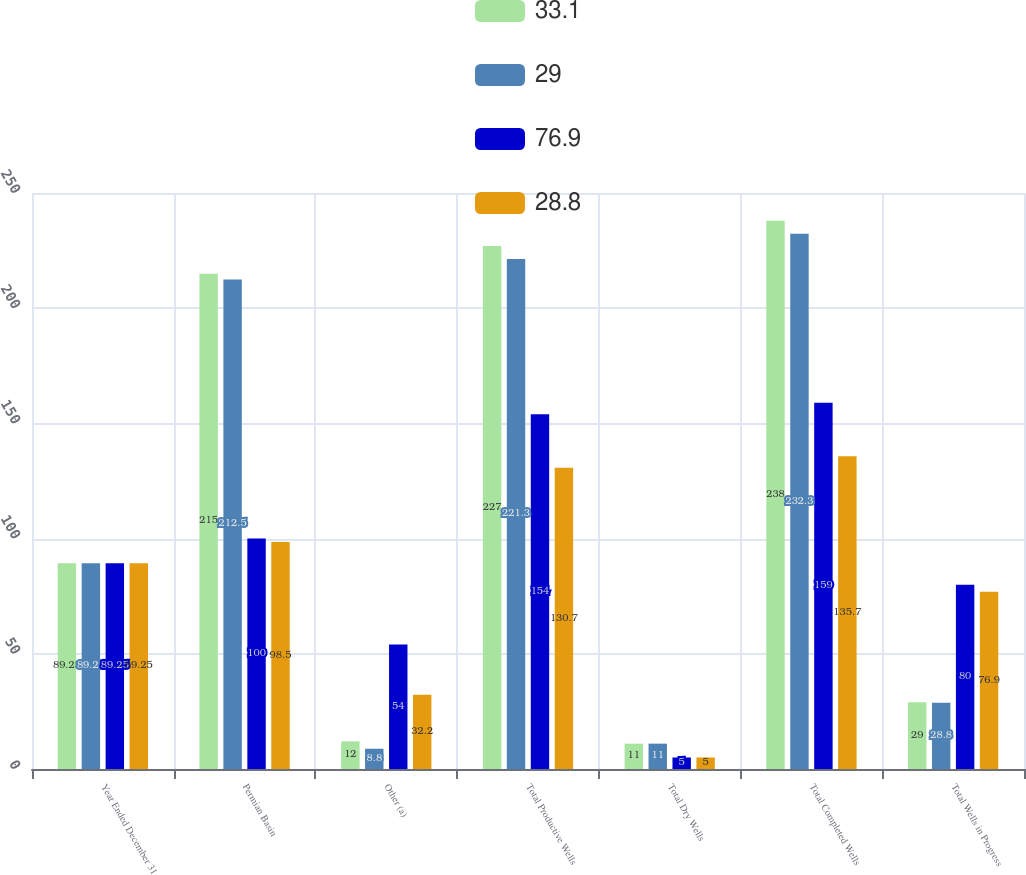Convert chart to OTSL. <chart><loc_0><loc_0><loc_500><loc_500><stacked_bar_chart><ecel><fcel>Year Ended December 31<fcel>Permian Basin<fcel>Other (a)<fcel>Total Productive Wells<fcel>Total Dry Wells<fcel>Total Completed Wells<fcel>Total Wells in Progress<nl><fcel>33.1<fcel>89.25<fcel>215<fcel>12<fcel>227<fcel>11<fcel>238<fcel>29<nl><fcel>29<fcel>89.25<fcel>212.5<fcel>8.8<fcel>221.3<fcel>11<fcel>232.3<fcel>28.8<nl><fcel>76.9<fcel>89.25<fcel>100<fcel>54<fcel>154<fcel>5<fcel>159<fcel>80<nl><fcel>28.8<fcel>89.25<fcel>98.5<fcel>32.2<fcel>130.7<fcel>5<fcel>135.7<fcel>76.9<nl></chart> 